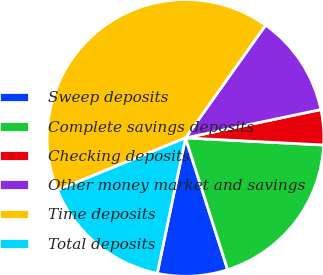Convert chart. <chart><loc_0><loc_0><loc_500><loc_500><pie_chart><fcel>Sweep deposits<fcel>Complete savings deposits<fcel>Checking deposits<fcel>Other money market and savings<fcel>Time deposits<fcel>Total deposits<nl><fcel>8.2%<fcel>19.26%<fcel>4.1%<fcel>11.89%<fcel>40.98%<fcel>15.57%<nl></chart> 